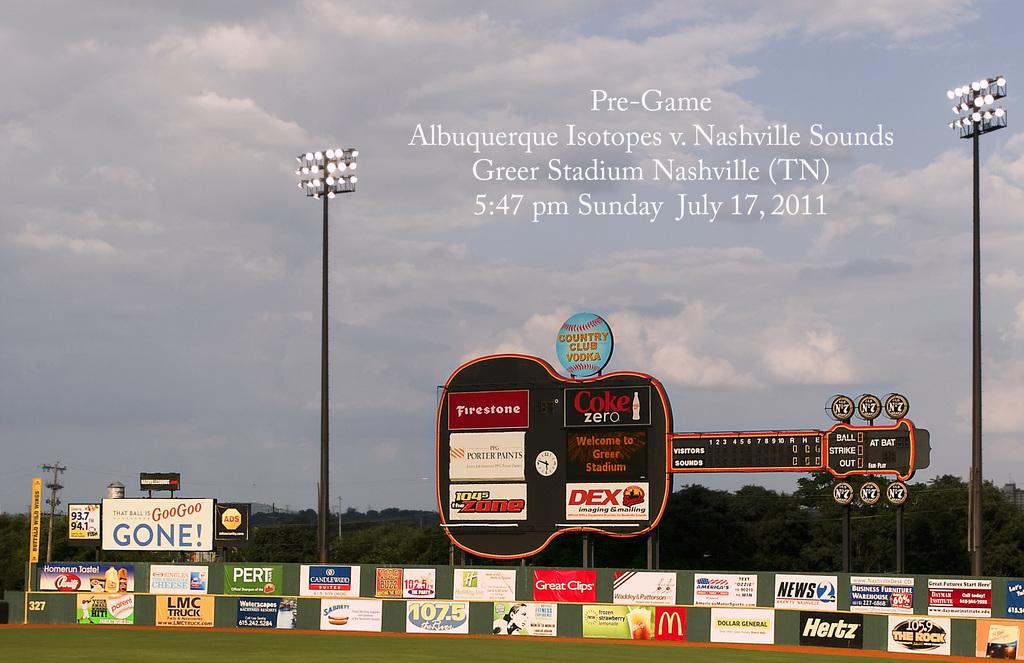Provide a one-sentence caption for the provided image. A picture of a field is used to advertise the time of a Pre-Game gathering. 